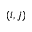<formula> <loc_0><loc_0><loc_500><loc_500>( i , j )</formula> 